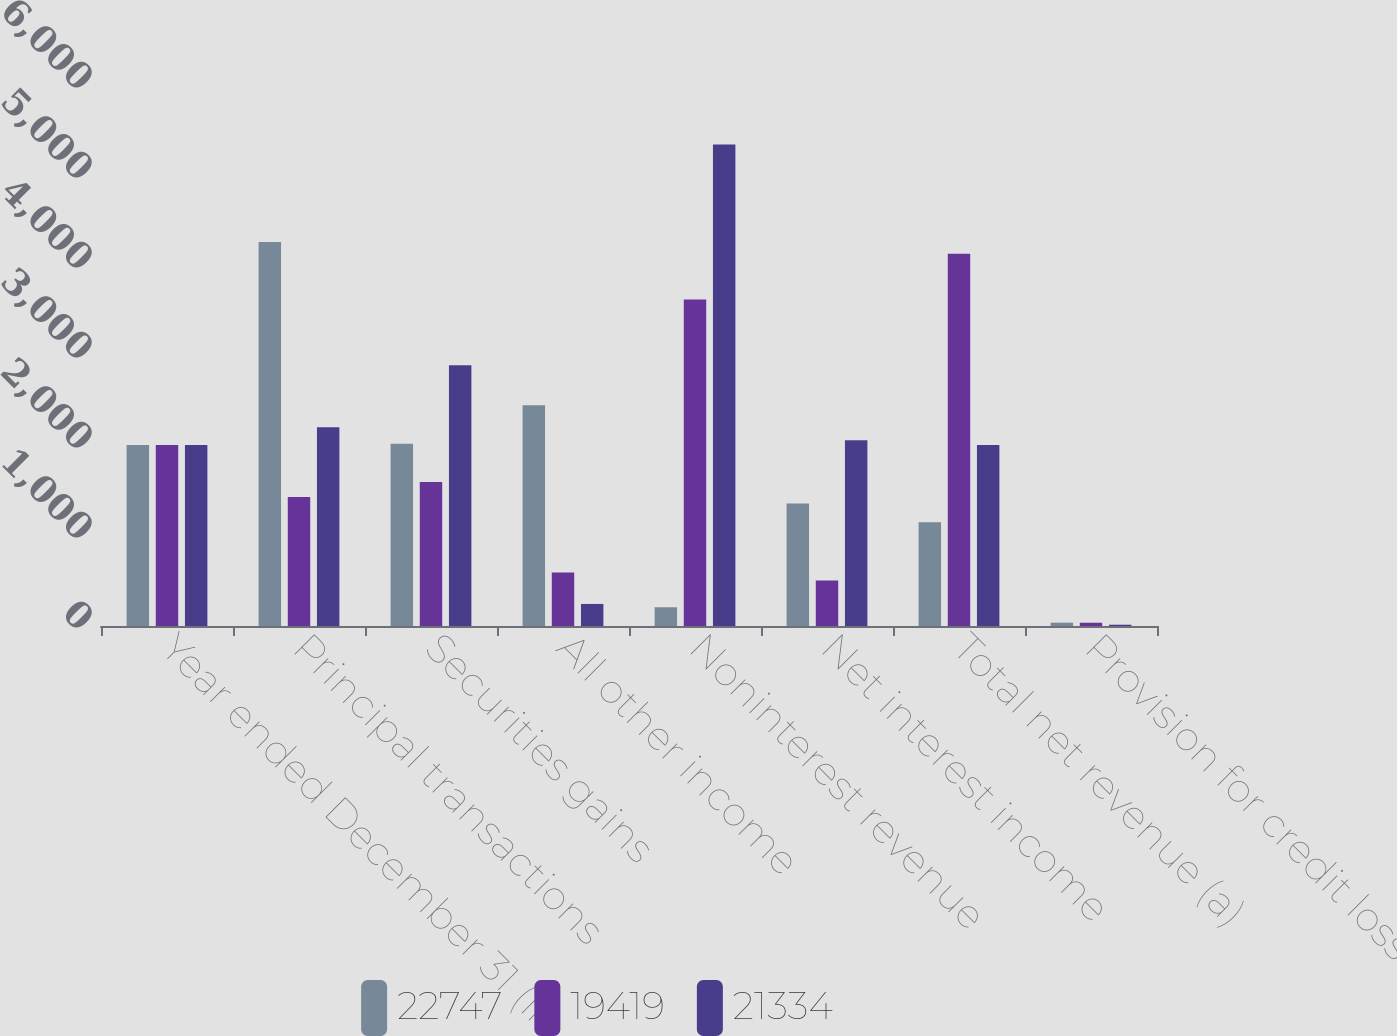Convert chart. <chart><loc_0><loc_0><loc_500><loc_500><stacked_bar_chart><ecel><fcel>Year ended December 31 (in<fcel>Principal transactions<fcel>Securities gains<fcel>All other income<fcel>Noninterest revenue<fcel>Net interest income<fcel>Total net revenue (a)<fcel>Provision for credit losses<nl><fcel>22747<fcel>2012<fcel>4268<fcel>2024<fcel>2452<fcel>208<fcel>1360<fcel>1152<fcel>37<nl><fcel>19419<fcel>2011<fcel>1434<fcel>1600<fcel>595<fcel>3629<fcel>506<fcel>4135<fcel>36<nl><fcel>21334<fcel>2010<fcel>2208<fcel>2898<fcel>245<fcel>5351<fcel>2063<fcel>2010<fcel>14<nl></chart> 